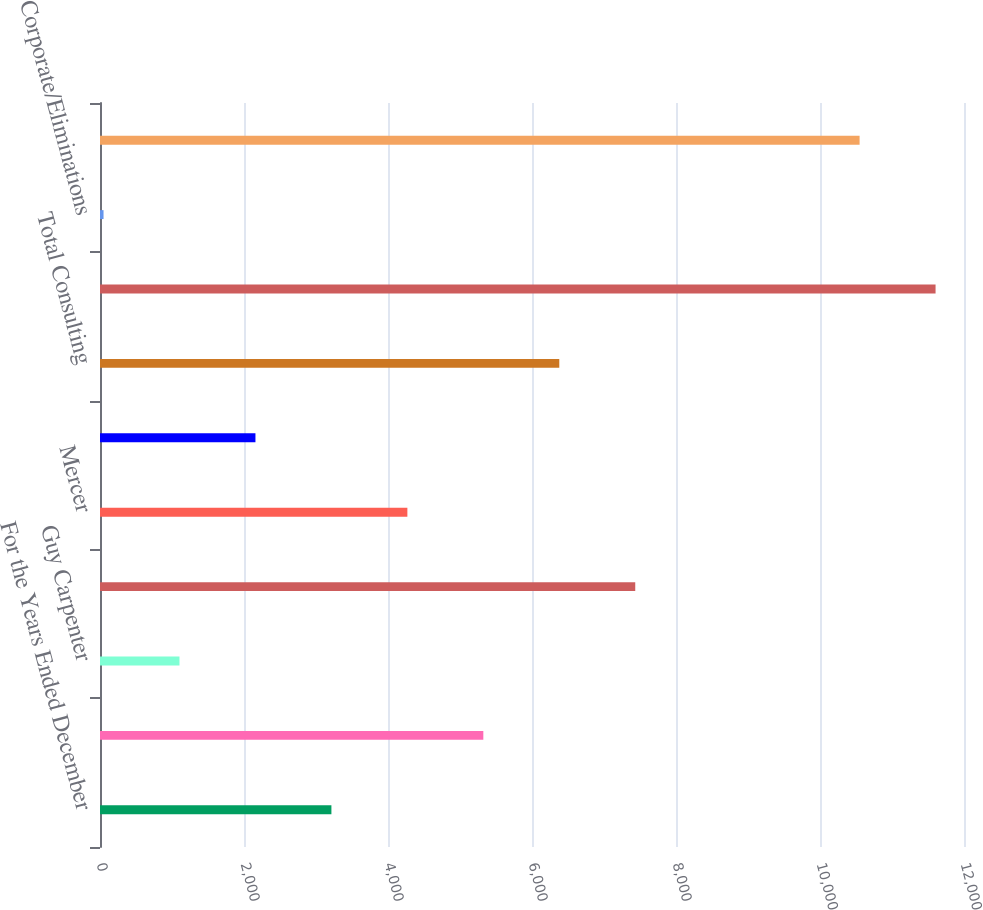Convert chart. <chart><loc_0><loc_0><loc_500><loc_500><bar_chart><fcel>For the Years Ended December<fcel>Marsh<fcel>Guy Carpenter<fcel>Total Risk and Insurance<fcel>Mercer<fcel>Oliver Wyman Group<fcel>Total Consulting<fcel>Total Operating Segments<fcel>Corporate/Eliminations<fcel>Total<nl><fcel>3214<fcel>5324<fcel>1104<fcel>7434<fcel>4269<fcel>2159<fcel>6379<fcel>11605<fcel>49<fcel>10550<nl></chart> 